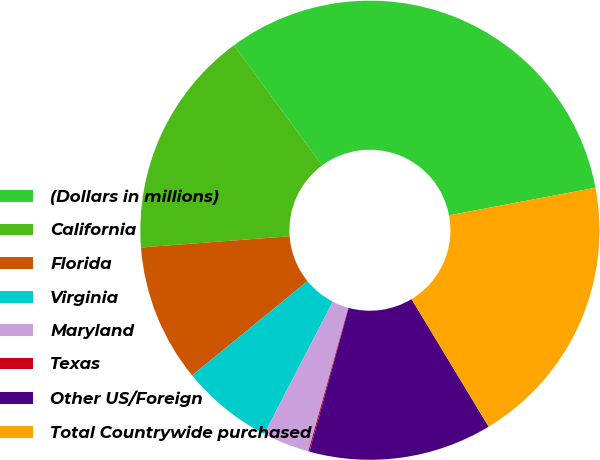Convert chart. <chart><loc_0><loc_0><loc_500><loc_500><pie_chart><fcel>(Dollars in millions)<fcel>California<fcel>Florida<fcel>Virginia<fcel>Maryland<fcel>Texas<fcel>Other US/Foreign<fcel>Total Countrywide purchased<nl><fcel>32.13%<fcel>16.11%<fcel>9.7%<fcel>6.49%<fcel>3.29%<fcel>0.08%<fcel>12.9%<fcel>19.31%<nl></chart> 